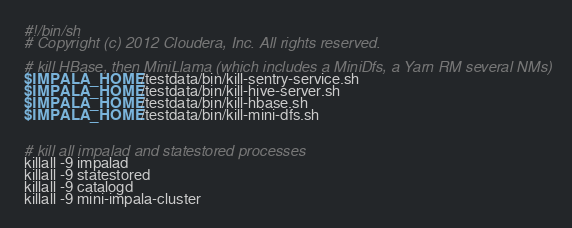Convert code to text. <code><loc_0><loc_0><loc_500><loc_500><_Bash_>#!/bin/sh
# Copyright (c) 2012 Cloudera, Inc. All rights reserved.

# kill HBase, then MiniLlama (which includes a MiniDfs, a Yarn RM several NMs)
$IMPALA_HOME/testdata/bin/kill-sentry-service.sh
$IMPALA_HOME/testdata/bin/kill-hive-server.sh
$IMPALA_HOME/testdata/bin/kill-hbase.sh
$IMPALA_HOME/testdata/bin/kill-mini-dfs.sh


# kill all impalad and statestored processes
killall -9 impalad
killall -9 statestored
killall -9 catalogd
killall -9 mini-impala-cluster
</code> 